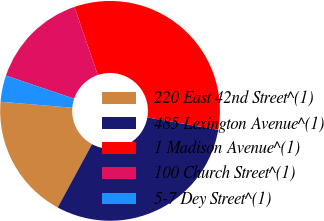Convert chart to OTSL. <chart><loc_0><loc_0><loc_500><loc_500><pie_chart><fcel>220 East 42nd Street^(1)<fcel>485 Lexington Avenue^(1)<fcel>1 Madison Avenue^(1)<fcel>100 Church Street^(1)<fcel>5-7 Dey Street^(1)<nl><fcel>18.42%<fcel>30.14%<fcel>33.01%<fcel>14.55%<fcel>3.88%<nl></chart> 